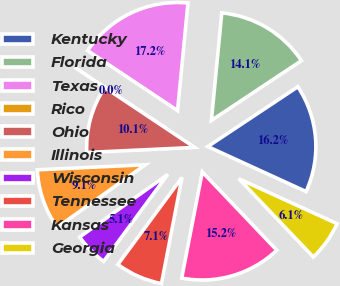Convert chart. <chart><loc_0><loc_0><loc_500><loc_500><pie_chart><fcel>Kentucky<fcel>Florida<fcel>Texas<fcel>Rico<fcel>Ohio<fcel>Illinois<fcel>Wisconsin<fcel>Tennessee<fcel>Kansas<fcel>Georgia<nl><fcel>16.16%<fcel>14.14%<fcel>17.17%<fcel>0.0%<fcel>10.1%<fcel>9.09%<fcel>5.05%<fcel>7.07%<fcel>15.15%<fcel>6.06%<nl></chart> 